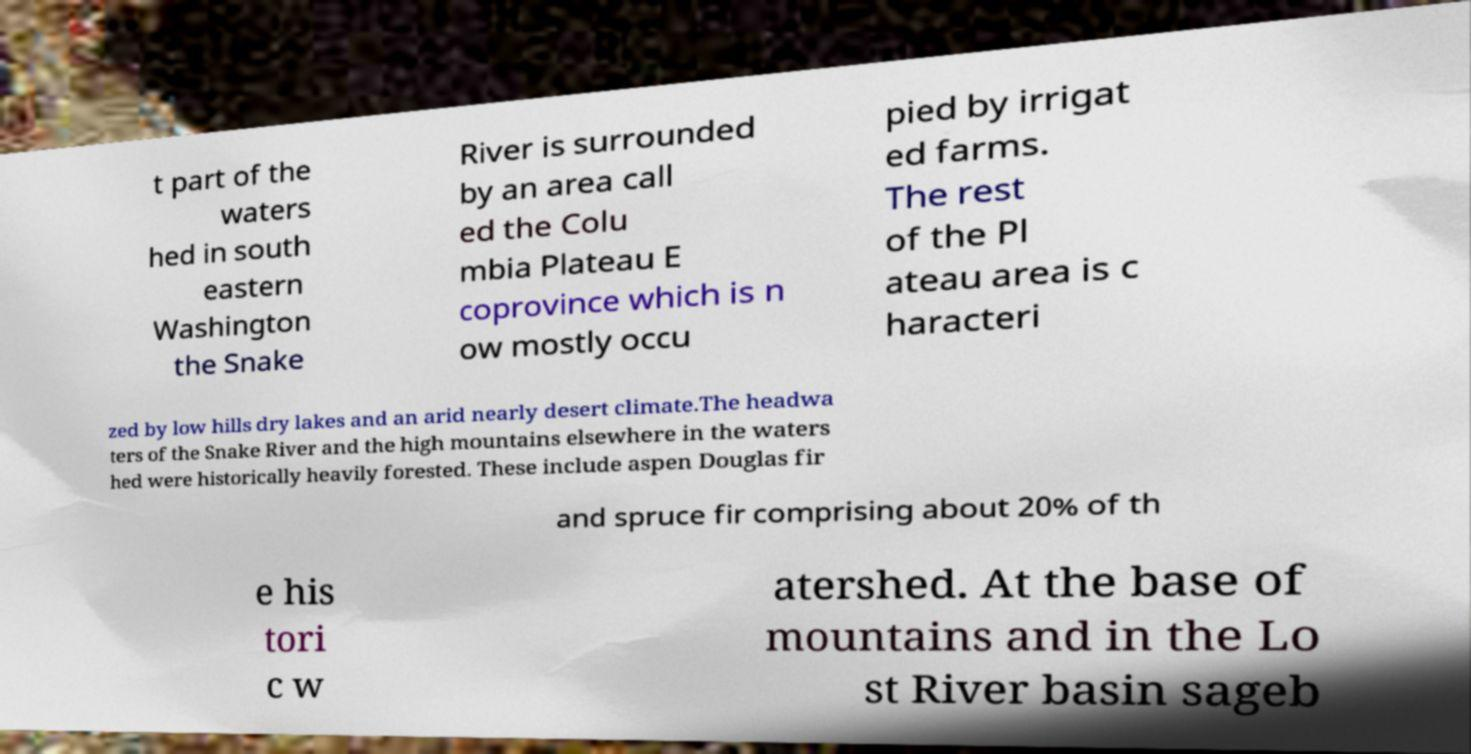Please read and relay the text visible in this image. What does it say? t part of the waters hed in south eastern Washington the Snake River is surrounded by an area call ed the Colu mbia Plateau E coprovince which is n ow mostly occu pied by irrigat ed farms. The rest of the Pl ateau area is c haracteri zed by low hills dry lakes and an arid nearly desert climate.The headwa ters of the Snake River and the high mountains elsewhere in the waters hed were historically heavily forested. These include aspen Douglas fir and spruce fir comprising about 20% of th e his tori c w atershed. At the base of mountains and in the Lo st River basin sageb 